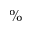Convert formula to latex. <formula><loc_0><loc_0><loc_500><loc_500>\%</formula> 